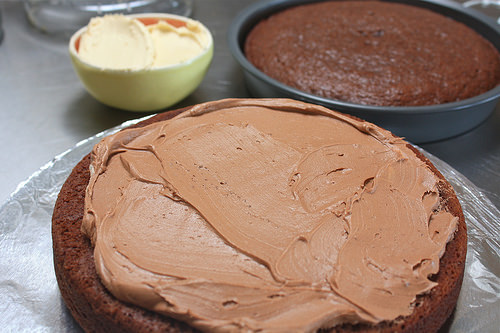<image>
Can you confirm if the butter is in the cake? No. The butter is not contained within the cake. These objects have a different spatial relationship. 